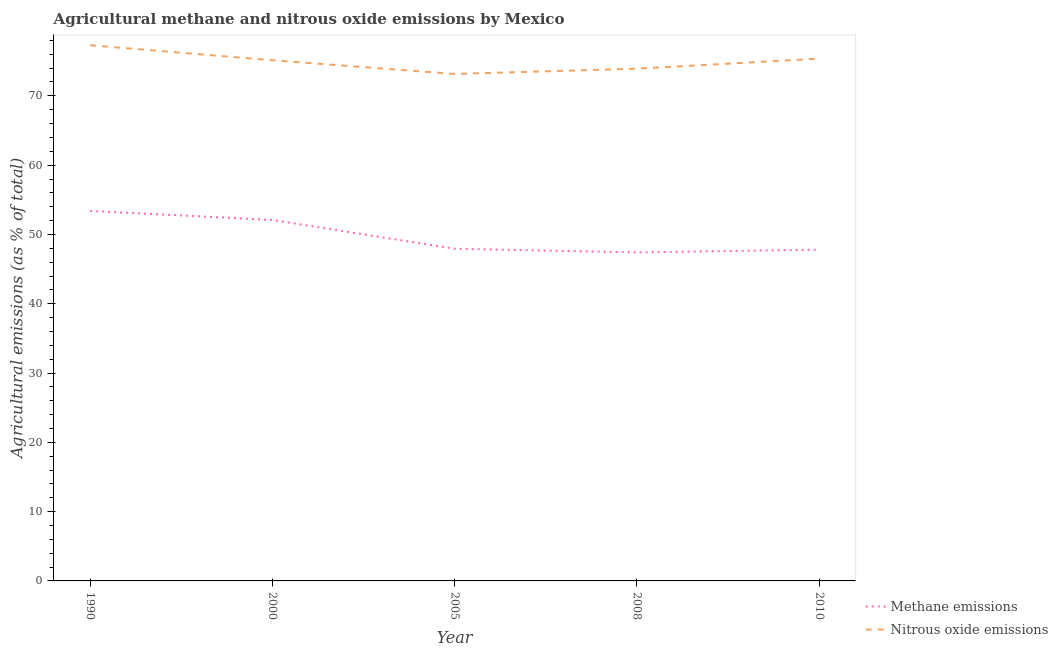Does the line corresponding to amount of nitrous oxide emissions intersect with the line corresponding to amount of methane emissions?
Your response must be concise. No. Is the number of lines equal to the number of legend labels?
Your answer should be compact. Yes. What is the amount of nitrous oxide emissions in 2008?
Your answer should be compact. 73.92. Across all years, what is the maximum amount of nitrous oxide emissions?
Provide a short and direct response. 77.3. Across all years, what is the minimum amount of methane emissions?
Provide a short and direct response. 47.41. In which year was the amount of methane emissions maximum?
Your response must be concise. 1990. What is the total amount of nitrous oxide emissions in the graph?
Your answer should be compact. 374.89. What is the difference between the amount of methane emissions in 1990 and that in 2008?
Keep it short and to the point. 5.98. What is the difference between the amount of nitrous oxide emissions in 2010 and the amount of methane emissions in 2000?
Keep it short and to the point. 23.28. What is the average amount of methane emissions per year?
Your response must be concise. 49.73. In the year 2008, what is the difference between the amount of nitrous oxide emissions and amount of methane emissions?
Your answer should be very brief. 26.51. In how many years, is the amount of methane emissions greater than 62 %?
Your response must be concise. 0. What is the ratio of the amount of methane emissions in 2000 to that in 2010?
Ensure brevity in your answer.  1.09. Is the amount of methane emissions in 2000 less than that in 2005?
Your response must be concise. No. What is the difference between the highest and the second highest amount of methane emissions?
Your response must be concise. 1.3. What is the difference between the highest and the lowest amount of nitrous oxide emissions?
Offer a very short reply. 4.15. In how many years, is the amount of methane emissions greater than the average amount of methane emissions taken over all years?
Make the answer very short. 2. Does the amount of methane emissions monotonically increase over the years?
Make the answer very short. No. Is the amount of methane emissions strictly greater than the amount of nitrous oxide emissions over the years?
Keep it short and to the point. No. Is the amount of methane emissions strictly less than the amount of nitrous oxide emissions over the years?
Your response must be concise. Yes. How many lines are there?
Your answer should be compact. 2. How many years are there in the graph?
Offer a very short reply. 5. What is the difference between two consecutive major ticks on the Y-axis?
Make the answer very short. 10. Are the values on the major ticks of Y-axis written in scientific E-notation?
Offer a very short reply. No. Does the graph contain any zero values?
Offer a terse response. No. Does the graph contain grids?
Make the answer very short. No. Where does the legend appear in the graph?
Give a very brief answer. Bottom right. How many legend labels are there?
Make the answer very short. 2. What is the title of the graph?
Provide a short and direct response. Agricultural methane and nitrous oxide emissions by Mexico. What is the label or title of the Y-axis?
Provide a succinct answer. Agricultural emissions (as % of total). What is the Agricultural emissions (as % of total) in Methane emissions in 1990?
Offer a very short reply. 53.39. What is the Agricultural emissions (as % of total) of Nitrous oxide emissions in 1990?
Give a very brief answer. 77.3. What is the Agricultural emissions (as % of total) of Methane emissions in 2000?
Give a very brief answer. 52.09. What is the Agricultural emissions (as % of total) of Nitrous oxide emissions in 2000?
Offer a very short reply. 75.14. What is the Agricultural emissions (as % of total) in Methane emissions in 2005?
Keep it short and to the point. 47.93. What is the Agricultural emissions (as % of total) of Nitrous oxide emissions in 2005?
Provide a succinct answer. 73.16. What is the Agricultural emissions (as % of total) of Methane emissions in 2008?
Make the answer very short. 47.41. What is the Agricultural emissions (as % of total) in Nitrous oxide emissions in 2008?
Your answer should be very brief. 73.92. What is the Agricultural emissions (as % of total) in Methane emissions in 2010?
Offer a very short reply. 47.81. What is the Agricultural emissions (as % of total) of Nitrous oxide emissions in 2010?
Ensure brevity in your answer.  75.37. Across all years, what is the maximum Agricultural emissions (as % of total) of Methane emissions?
Your answer should be very brief. 53.39. Across all years, what is the maximum Agricultural emissions (as % of total) in Nitrous oxide emissions?
Your answer should be very brief. 77.3. Across all years, what is the minimum Agricultural emissions (as % of total) of Methane emissions?
Offer a terse response. 47.41. Across all years, what is the minimum Agricultural emissions (as % of total) in Nitrous oxide emissions?
Offer a terse response. 73.16. What is the total Agricultural emissions (as % of total) of Methane emissions in the graph?
Your answer should be compact. 248.63. What is the total Agricultural emissions (as % of total) of Nitrous oxide emissions in the graph?
Provide a succinct answer. 374.89. What is the difference between the Agricultural emissions (as % of total) of Methane emissions in 1990 and that in 2000?
Provide a succinct answer. 1.3. What is the difference between the Agricultural emissions (as % of total) in Nitrous oxide emissions in 1990 and that in 2000?
Your answer should be compact. 2.17. What is the difference between the Agricultural emissions (as % of total) in Methane emissions in 1990 and that in 2005?
Make the answer very short. 5.46. What is the difference between the Agricultural emissions (as % of total) of Nitrous oxide emissions in 1990 and that in 2005?
Offer a terse response. 4.15. What is the difference between the Agricultural emissions (as % of total) in Methane emissions in 1990 and that in 2008?
Make the answer very short. 5.98. What is the difference between the Agricultural emissions (as % of total) in Nitrous oxide emissions in 1990 and that in 2008?
Offer a terse response. 3.38. What is the difference between the Agricultural emissions (as % of total) of Methane emissions in 1990 and that in 2010?
Provide a short and direct response. 5.59. What is the difference between the Agricultural emissions (as % of total) of Nitrous oxide emissions in 1990 and that in 2010?
Make the answer very short. 1.93. What is the difference between the Agricultural emissions (as % of total) of Methane emissions in 2000 and that in 2005?
Give a very brief answer. 4.16. What is the difference between the Agricultural emissions (as % of total) of Nitrous oxide emissions in 2000 and that in 2005?
Your response must be concise. 1.98. What is the difference between the Agricultural emissions (as % of total) in Methane emissions in 2000 and that in 2008?
Ensure brevity in your answer.  4.68. What is the difference between the Agricultural emissions (as % of total) in Nitrous oxide emissions in 2000 and that in 2008?
Give a very brief answer. 1.21. What is the difference between the Agricultural emissions (as % of total) of Methane emissions in 2000 and that in 2010?
Your answer should be compact. 4.29. What is the difference between the Agricultural emissions (as % of total) in Nitrous oxide emissions in 2000 and that in 2010?
Keep it short and to the point. -0.24. What is the difference between the Agricultural emissions (as % of total) in Methane emissions in 2005 and that in 2008?
Offer a terse response. 0.52. What is the difference between the Agricultural emissions (as % of total) in Nitrous oxide emissions in 2005 and that in 2008?
Give a very brief answer. -0.76. What is the difference between the Agricultural emissions (as % of total) of Methane emissions in 2005 and that in 2010?
Offer a very short reply. 0.13. What is the difference between the Agricultural emissions (as % of total) in Nitrous oxide emissions in 2005 and that in 2010?
Offer a very short reply. -2.21. What is the difference between the Agricultural emissions (as % of total) of Methane emissions in 2008 and that in 2010?
Keep it short and to the point. -0.4. What is the difference between the Agricultural emissions (as % of total) of Nitrous oxide emissions in 2008 and that in 2010?
Make the answer very short. -1.45. What is the difference between the Agricultural emissions (as % of total) of Methane emissions in 1990 and the Agricultural emissions (as % of total) of Nitrous oxide emissions in 2000?
Offer a very short reply. -21.74. What is the difference between the Agricultural emissions (as % of total) in Methane emissions in 1990 and the Agricultural emissions (as % of total) in Nitrous oxide emissions in 2005?
Offer a very short reply. -19.77. What is the difference between the Agricultural emissions (as % of total) of Methane emissions in 1990 and the Agricultural emissions (as % of total) of Nitrous oxide emissions in 2008?
Your response must be concise. -20.53. What is the difference between the Agricultural emissions (as % of total) in Methane emissions in 1990 and the Agricultural emissions (as % of total) in Nitrous oxide emissions in 2010?
Your answer should be compact. -21.98. What is the difference between the Agricultural emissions (as % of total) in Methane emissions in 2000 and the Agricultural emissions (as % of total) in Nitrous oxide emissions in 2005?
Your answer should be compact. -21.07. What is the difference between the Agricultural emissions (as % of total) in Methane emissions in 2000 and the Agricultural emissions (as % of total) in Nitrous oxide emissions in 2008?
Make the answer very short. -21.83. What is the difference between the Agricultural emissions (as % of total) of Methane emissions in 2000 and the Agricultural emissions (as % of total) of Nitrous oxide emissions in 2010?
Offer a terse response. -23.28. What is the difference between the Agricultural emissions (as % of total) of Methane emissions in 2005 and the Agricultural emissions (as % of total) of Nitrous oxide emissions in 2008?
Ensure brevity in your answer.  -25.99. What is the difference between the Agricultural emissions (as % of total) of Methane emissions in 2005 and the Agricultural emissions (as % of total) of Nitrous oxide emissions in 2010?
Your response must be concise. -27.44. What is the difference between the Agricultural emissions (as % of total) in Methane emissions in 2008 and the Agricultural emissions (as % of total) in Nitrous oxide emissions in 2010?
Give a very brief answer. -27.96. What is the average Agricultural emissions (as % of total) in Methane emissions per year?
Your answer should be very brief. 49.73. What is the average Agricultural emissions (as % of total) in Nitrous oxide emissions per year?
Provide a succinct answer. 74.98. In the year 1990, what is the difference between the Agricultural emissions (as % of total) in Methane emissions and Agricultural emissions (as % of total) in Nitrous oxide emissions?
Offer a very short reply. -23.91. In the year 2000, what is the difference between the Agricultural emissions (as % of total) in Methane emissions and Agricultural emissions (as % of total) in Nitrous oxide emissions?
Make the answer very short. -23.04. In the year 2005, what is the difference between the Agricultural emissions (as % of total) of Methane emissions and Agricultural emissions (as % of total) of Nitrous oxide emissions?
Provide a succinct answer. -25.23. In the year 2008, what is the difference between the Agricultural emissions (as % of total) in Methane emissions and Agricultural emissions (as % of total) in Nitrous oxide emissions?
Ensure brevity in your answer.  -26.51. In the year 2010, what is the difference between the Agricultural emissions (as % of total) of Methane emissions and Agricultural emissions (as % of total) of Nitrous oxide emissions?
Offer a terse response. -27.57. What is the ratio of the Agricultural emissions (as % of total) in Methane emissions in 1990 to that in 2000?
Offer a terse response. 1.02. What is the ratio of the Agricultural emissions (as % of total) in Nitrous oxide emissions in 1990 to that in 2000?
Ensure brevity in your answer.  1.03. What is the ratio of the Agricultural emissions (as % of total) in Methane emissions in 1990 to that in 2005?
Your answer should be very brief. 1.11. What is the ratio of the Agricultural emissions (as % of total) in Nitrous oxide emissions in 1990 to that in 2005?
Your answer should be compact. 1.06. What is the ratio of the Agricultural emissions (as % of total) in Methane emissions in 1990 to that in 2008?
Your answer should be very brief. 1.13. What is the ratio of the Agricultural emissions (as % of total) in Nitrous oxide emissions in 1990 to that in 2008?
Ensure brevity in your answer.  1.05. What is the ratio of the Agricultural emissions (as % of total) of Methane emissions in 1990 to that in 2010?
Keep it short and to the point. 1.12. What is the ratio of the Agricultural emissions (as % of total) of Nitrous oxide emissions in 1990 to that in 2010?
Offer a terse response. 1.03. What is the ratio of the Agricultural emissions (as % of total) of Methane emissions in 2000 to that in 2005?
Ensure brevity in your answer.  1.09. What is the ratio of the Agricultural emissions (as % of total) in Nitrous oxide emissions in 2000 to that in 2005?
Give a very brief answer. 1.03. What is the ratio of the Agricultural emissions (as % of total) in Methane emissions in 2000 to that in 2008?
Provide a succinct answer. 1.1. What is the ratio of the Agricultural emissions (as % of total) in Nitrous oxide emissions in 2000 to that in 2008?
Your answer should be very brief. 1.02. What is the ratio of the Agricultural emissions (as % of total) of Methane emissions in 2000 to that in 2010?
Offer a very short reply. 1.09. What is the ratio of the Agricultural emissions (as % of total) of Nitrous oxide emissions in 2000 to that in 2010?
Keep it short and to the point. 1. What is the ratio of the Agricultural emissions (as % of total) of Methane emissions in 2005 to that in 2008?
Keep it short and to the point. 1.01. What is the ratio of the Agricultural emissions (as % of total) of Nitrous oxide emissions in 2005 to that in 2010?
Your answer should be compact. 0.97. What is the ratio of the Agricultural emissions (as % of total) in Methane emissions in 2008 to that in 2010?
Keep it short and to the point. 0.99. What is the ratio of the Agricultural emissions (as % of total) in Nitrous oxide emissions in 2008 to that in 2010?
Offer a very short reply. 0.98. What is the difference between the highest and the second highest Agricultural emissions (as % of total) of Methane emissions?
Your answer should be compact. 1.3. What is the difference between the highest and the second highest Agricultural emissions (as % of total) of Nitrous oxide emissions?
Your answer should be very brief. 1.93. What is the difference between the highest and the lowest Agricultural emissions (as % of total) of Methane emissions?
Keep it short and to the point. 5.98. What is the difference between the highest and the lowest Agricultural emissions (as % of total) of Nitrous oxide emissions?
Offer a terse response. 4.15. 